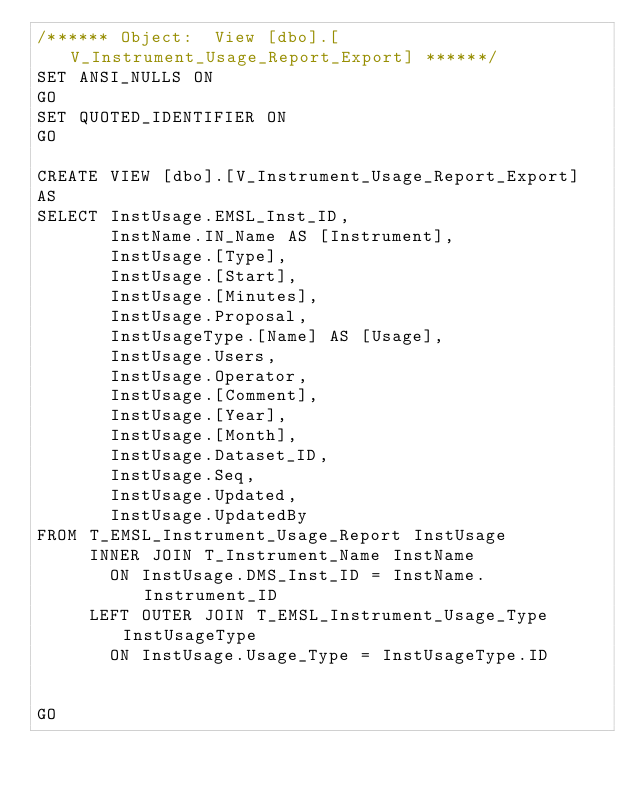<code> <loc_0><loc_0><loc_500><loc_500><_SQL_>/****** Object:  View [dbo].[V_Instrument_Usage_Report_Export] ******/
SET ANSI_NULLS ON
GO
SET QUOTED_IDENTIFIER ON
GO

CREATE VIEW [dbo].[V_Instrument_Usage_Report_Export]
AS
SELECT InstUsage.EMSL_Inst_ID,
       InstName.IN_Name AS [Instrument],
       InstUsage.[Type],
       InstUsage.[Start],
       InstUsage.[Minutes],
       InstUsage.Proposal,
       InstUsageType.[Name] AS [Usage],
       InstUsage.Users,
       InstUsage.Operator,
       InstUsage.[Comment],
       InstUsage.[Year],
       InstUsage.[Month],
       InstUsage.Dataset_ID,
	   InstUsage.Seq,       
       InstUsage.Updated,
	   InstUsage.UpdatedBy
FROM T_EMSL_Instrument_Usage_Report InstUsage
     INNER JOIN T_Instrument_Name InstName
       ON InstUsage.DMS_Inst_ID = InstName.Instrument_ID
     LEFT OUTER JOIN T_EMSL_Instrument_Usage_Type InstUsageType
       ON InstUsage.Usage_Type = InstUsageType.ID


GO
</code> 